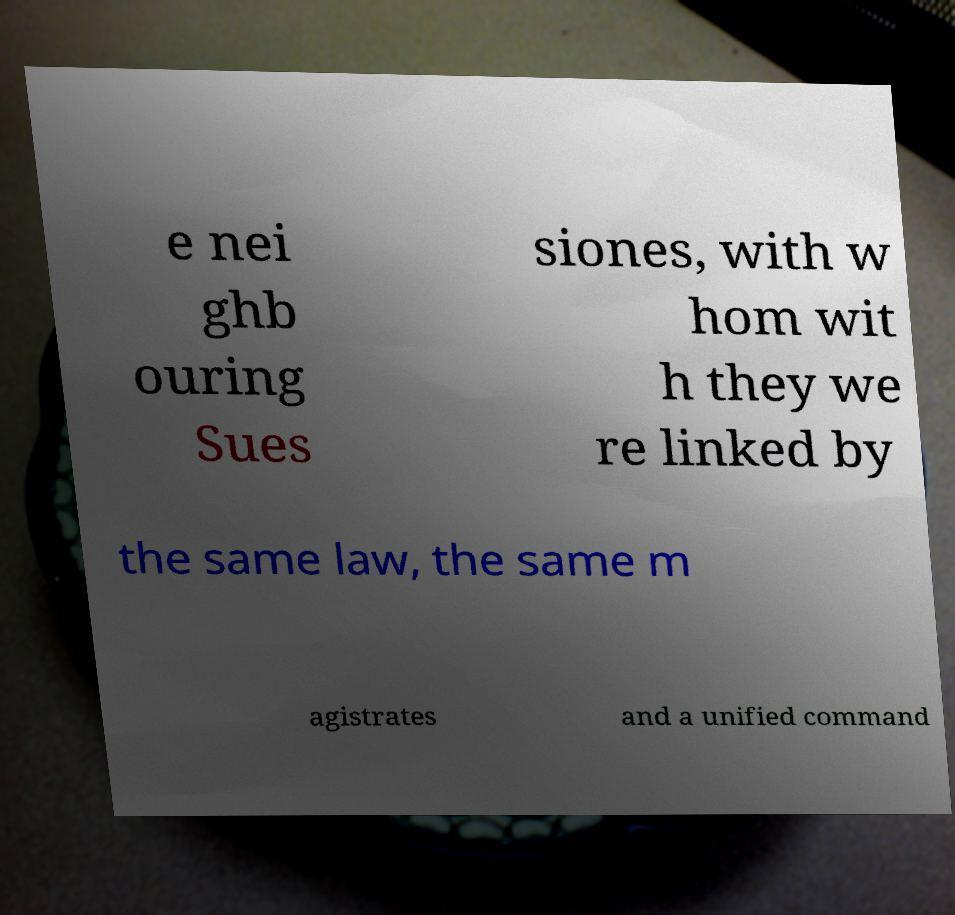Can you read and provide the text displayed in the image?This photo seems to have some interesting text. Can you extract and type it out for me? e nei ghb ouring Sues siones, with w hom wit h they we re linked by the same law, the same m agistrates and a unified command 